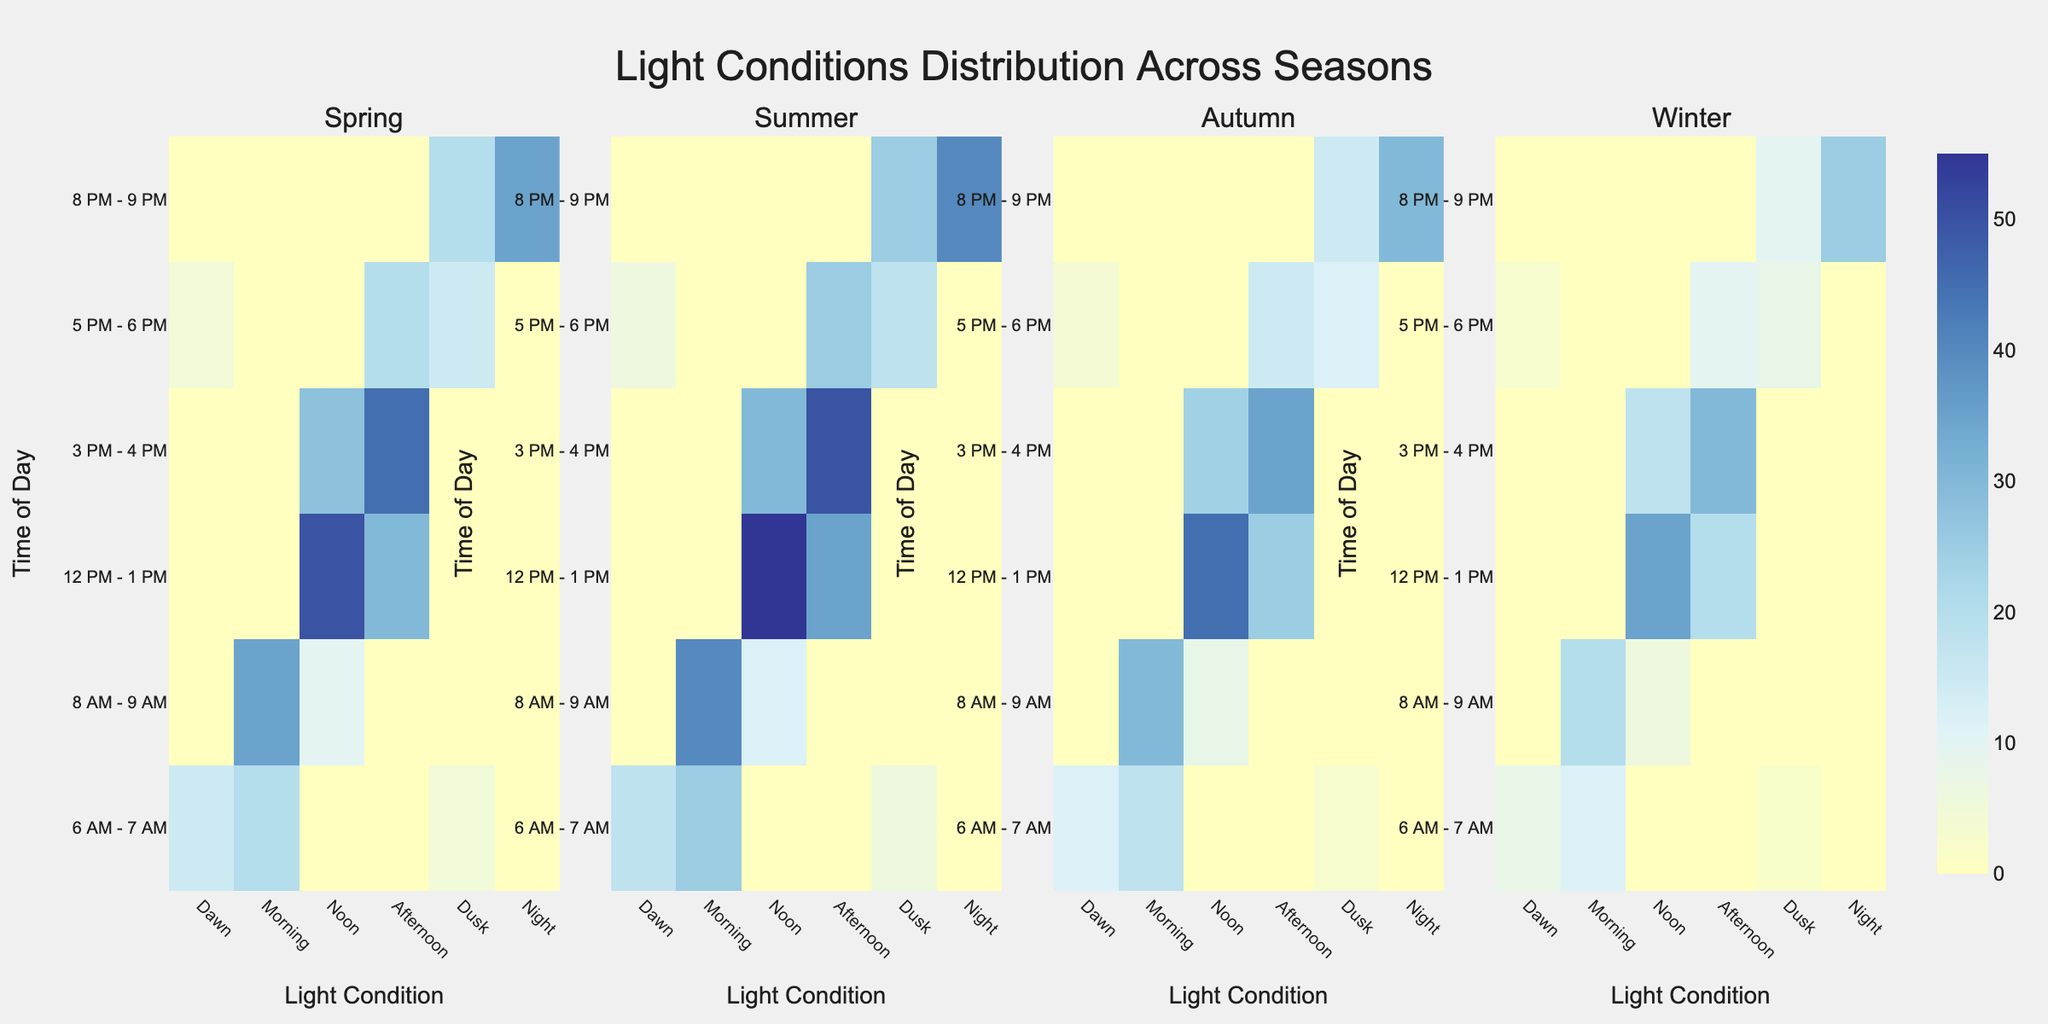what is the overall title of the figure? The overall title can be found at the top of the plot and usually describes the main topic or content of the figure. Here, it reads "Light Conditions Distribution Across Seasons".
Answer: Light Conditions Distribution Across Seasons Which light condition has the highest number of photos taken at noon during summer? We focus on the subplot titled "Summer," then look at the row labeled "12 PM - 1 PM" and the column labeled "Noon". The cell value indicates the number of photos taken during this condition.
Answer: 55 Compare the number of photos taken during dawn in spring vs. autumn for the 6 AM - 7 AM time slot. Which season has more, and by how much? First, locate the Spring subplot and find the intersection of "6 AM - 7 AM" and "Dawn," which is 15. Next, do the same for Autumn, which is 12. Subtract the lower value from the higher value.
Answer: Spring has 3 more Which time of day has the least variance in the number of photos taken across all seasons? Examine the cells for each time slot across all seasons and compare the ranges. The time slot with the smallest range of values has the least variance. Noon (12 PM - 1 PM) has very close values (Spring:50,Summer:55,Autumn:45,Winter:35), indicating low variance.
Answer: Noon (12 PM - 1 PM) Are there any time slots where no photos were taken regardless of the season or light condition? Check all time slots across every condition in every subplot for cells with a value of 0. We find that there are no 0s across all subplots and conditions for the specified times.
Answer: No In which season and during which light condition is maximum photo activity recorded at the 3 PM - 4 PM time slot? Look for the cell with the highest value in the "3 PM - 4 PM" row of each subplot. The maximum value in any condition and season is "50" during "Afternoon" in Summer.
Answer: Summer, Afternoon How does the number of photos taken during dusk compare between spring and winter? Check the values under the "Dusk" column for both the Spring and Winter subplots. Spring shows 20 photos, and Winter shows 10 photos.
Answer: Spring has 10 more than Winter For the 8 PM - 9 PM time slot, which season records the highest number of night-time photos? Focus on the "8 PM - 9 PM" row and the "Night" column in each season's subplot. The highest value recorded is 40 in Summer.
Answer: Summer What is the total number of photos taken in the morning (8 AM - 9 AM) across all seasons? Add the values in the "Morning" column for the "8 AM - 9 AM" row in each subplot. Spring: 35, Summer: 40, Autumn: 30, Winter: 20. The total sum is (35+40+30+20).
Answer: 125 Do dusk photos show a significant increase during any particular season? If so, which season? Compare the values in the "Dusk" column across all seasons. Notably, Summer shows a relatively higher count (25) compared to the other seasons, indicating a significant increase.
Answer: Summer 